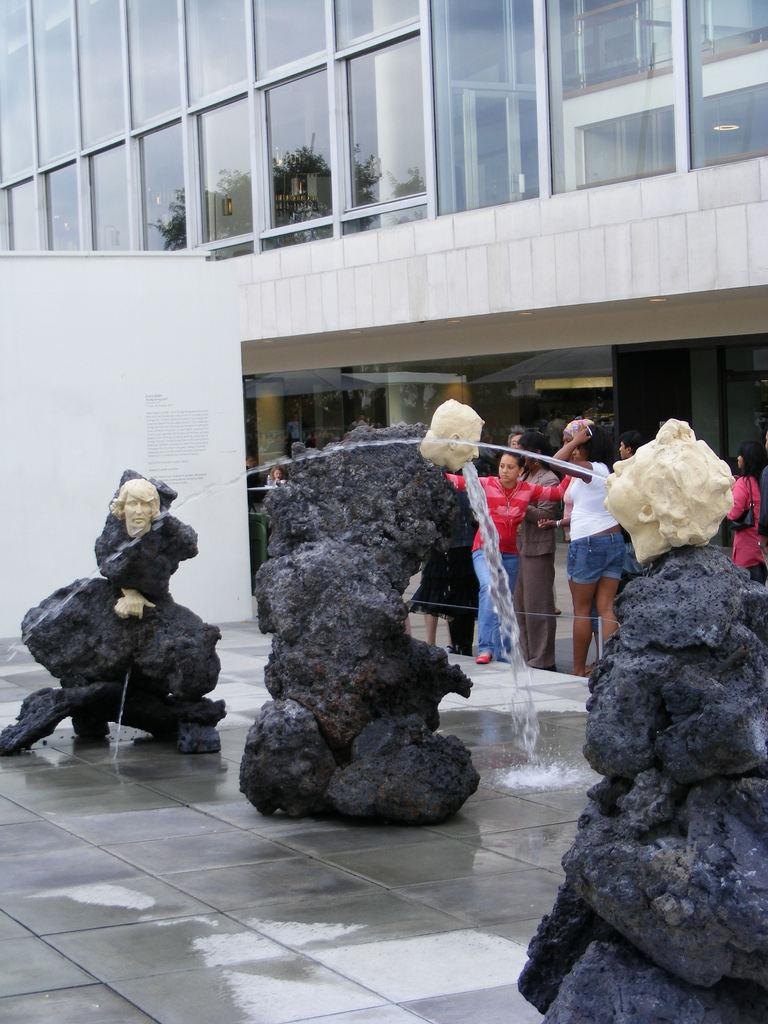What is the main feature in the image? There is a fountain in the image. Are there any people in the image? Yes, there are people near the fountain. What type of structure can be seen in the image? There is a building in the image. What is the building covered with? The building is covered with glass. Can you tell me how many basketballs are being controlled by the people in the image? There are no basketballs present in the image, so it is not possible to determine how many are being controlled. 